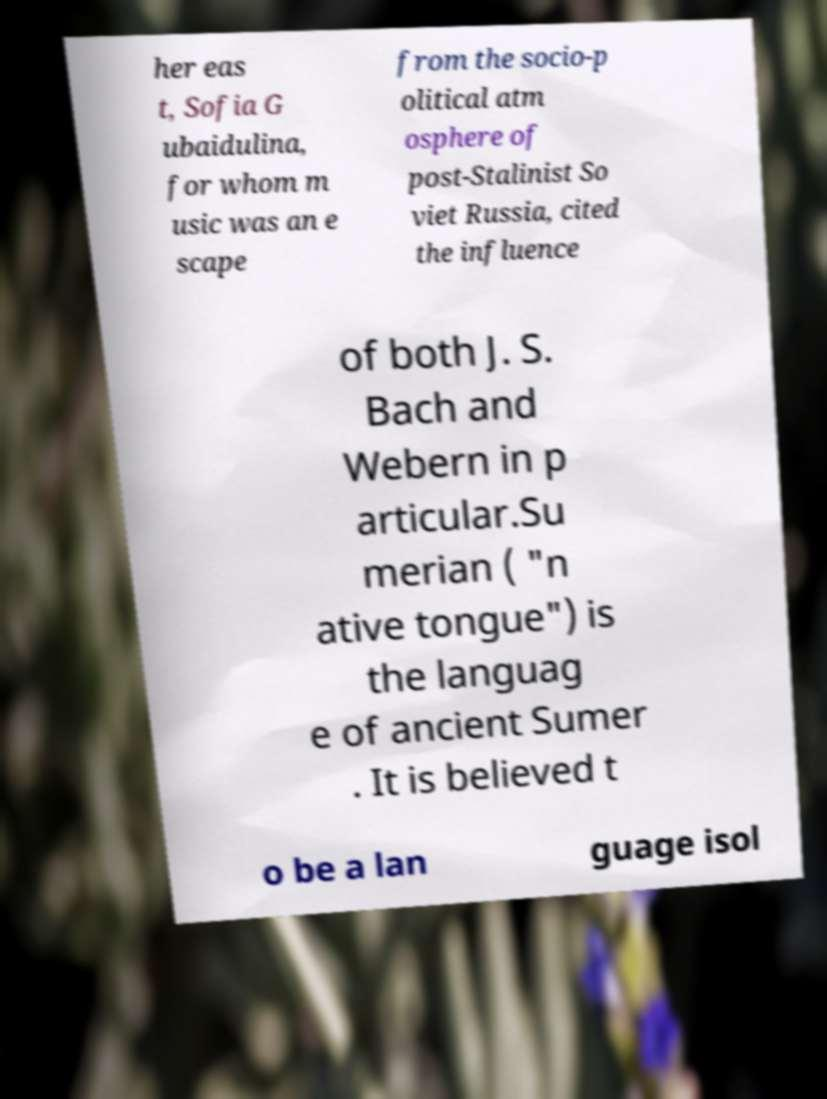What messages or text are displayed in this image? I need them in a readable, typed format. her eas t, Sofia G ubaidulina, for whom m usic was an e scape from the socio-p olitical atm osphere of post-Stalinist So viet Russia, cited the influence of both J. S. Bach and Webern in p articular.Su merian ( "n ative tongue") is the languag e of ancient Sumer . It is believed t o be a lan guage isol 